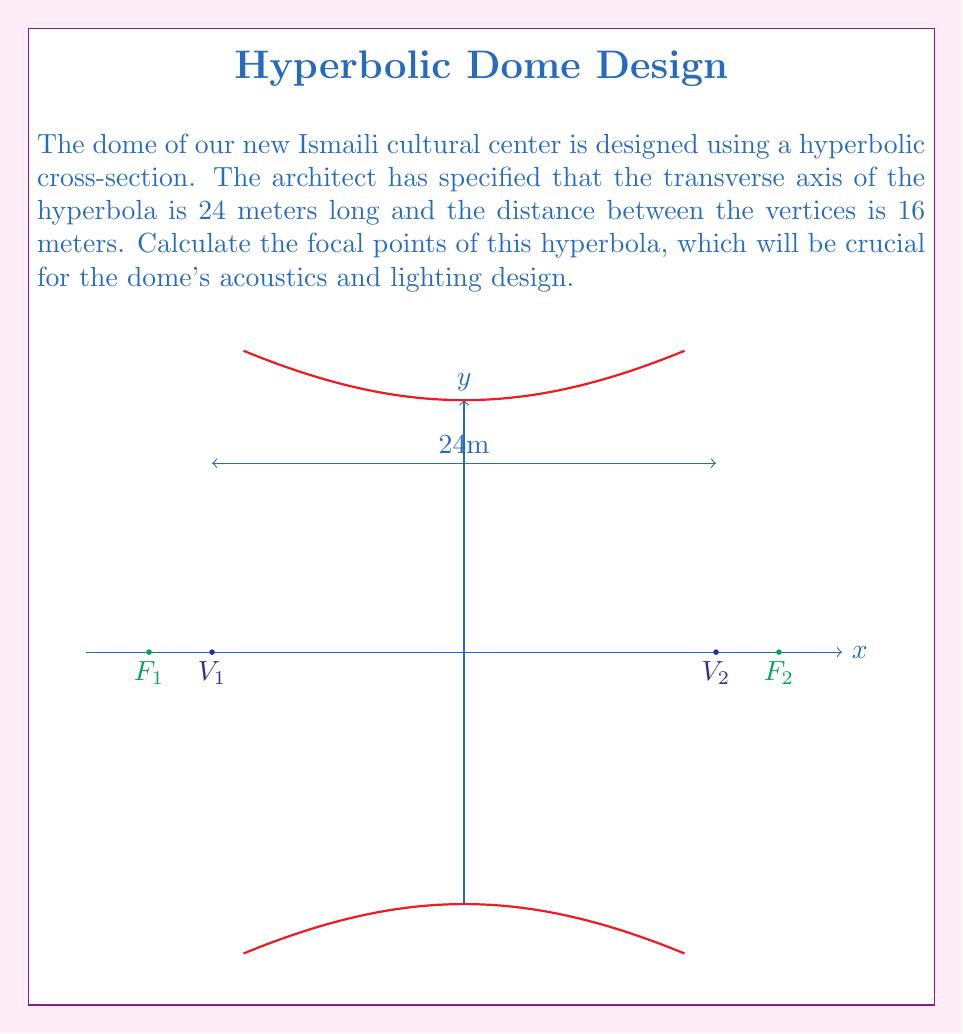What is the answer to this math problem? Let's approach this step-by-step:

1) In a hyperbola, we define:
   $a$ = half the distance between the vertices
   $c$ = distance from the center to a focus
   $b$ = the length of the conjugate axis

2) We're given that the transverse axis is 24 meters long, so:
   $2a = 24$
   $a = 12$ meters

3) We're also told that the distance between the vertices is 16 meters:
   $2a = 16$
   $a = 8$ meters

4) For a hyperbola, we use the equation:
   $c^2 = a^2 + b^2$

5) We don't know $b$, but we can find it using the given information:
   $a = 8$
   $c = 12$ (half of the transverse axis)

6) Substituting into the equation:
   $12^2 = 8^2 + b^2$
   $144 = 64 + b^2$
   $b^2 = 80$
   $b = \sqrt{80} = 4\sqrt{5}$ meters

7) Now we can confirm:
   $c^2 = a^2 + b^2$
   $12^2 = 8^2 + (4\sqrt{5})^2$
   $144 = 64 + 80$
   $144 = 144$ (This checks out)

8) The focal points are located at $(±c, 0)$ on the transverse axis.
   So, the focal points are at $(-12, 0)$ and $(12, 0)$.
Answer: $(-12, 0)$ and $(12, 0)$ meters from the center 